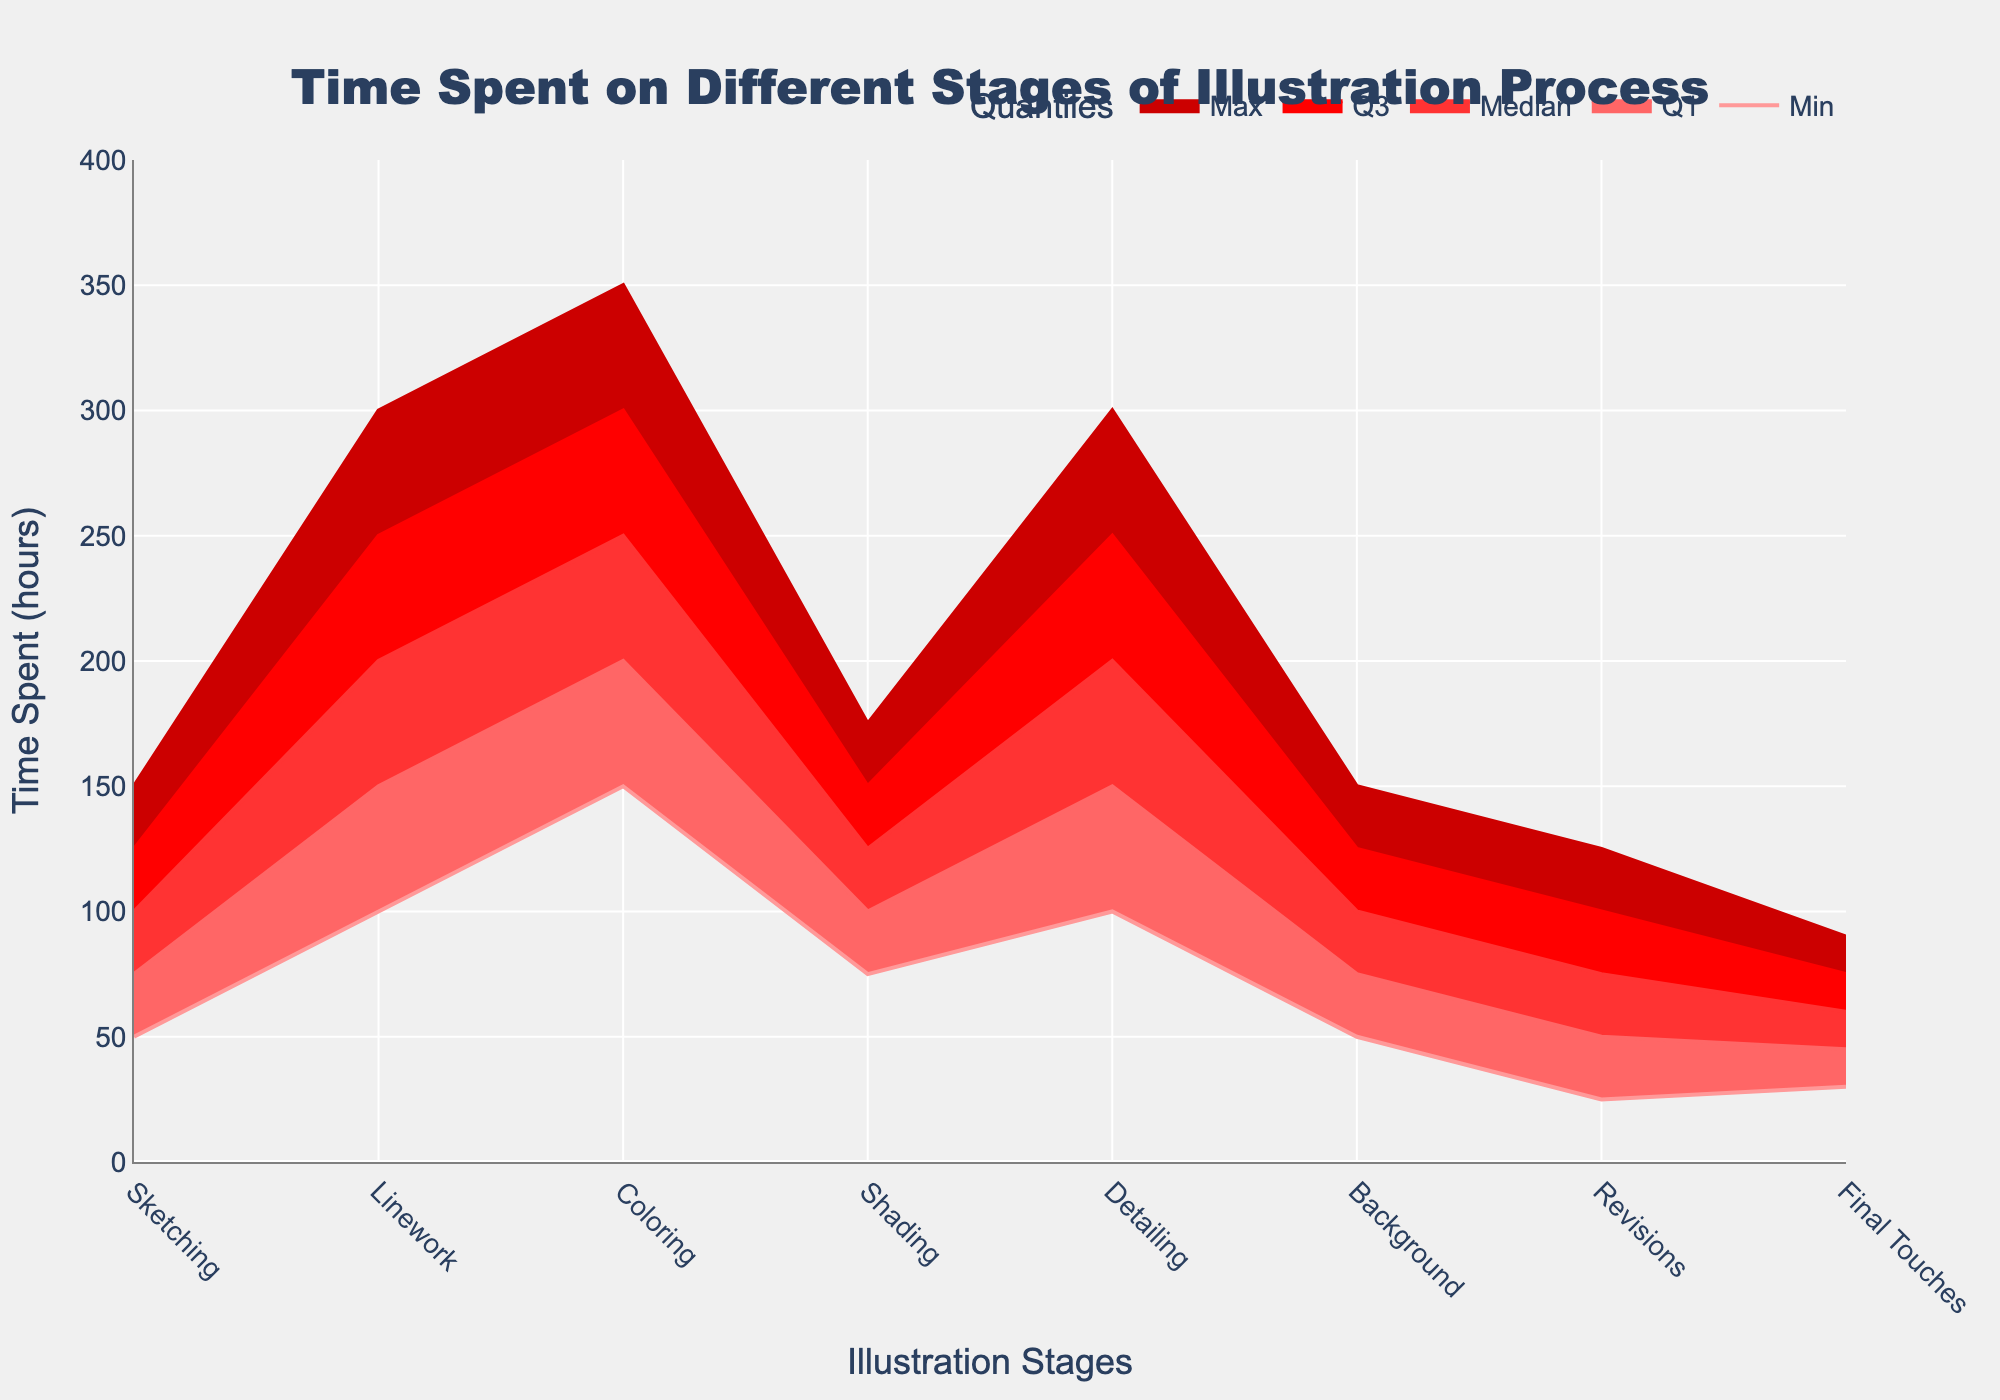How many stages are listed in the fan chart? To find the number of stages listed in the fan chart, count the unique stages labeled on the x-axis.
Answer: 8 What is the median time spent on the Coloring stage? Locate the stage "Coloring" on the x-axis, then identify the value corresponding to the "Median" line.
Answer: 250 hours Which stage has the highest maximum time spent? For each stage, note the value of the line representing the "Max" time. The stage with the highest value is the one with the maximum time spent.
Answer: Coloring What is the interquartile range (IQR) for the Shading stage? To calculate the IQR, subtract the Q1 value from the Q3 value for the Shading stage: Q3 - Q1.
Answer: 50 hours Compare the median times of Linework and Detailing stages. Which stage has a higher median time? Locate the values corresponding to the "Median" lines for both Linework and Detailing stages. Compare these values.
Answer: Linework What stage has the most consistency in time spent, based on the spread from Min to Max values? The stage with the smallest difference between its Min and Max values has the most consistent time spent. Calculate the difference for each stage and compare.
Answer: Final Touches What is the range of time spent on the Background stage? Subtract the Min value from the Max value for the Background stage to find the range (Max - Min).
Answer: 100 hours Which stages have a similar Q3 value for time spent? Identify the Q3 values for each stage and compare them to find stages with similar Q3 values.
Answer: Linework and Detailing What is the minimum time spent on Revisions? Locate the "Min" value for the Revisions stage on the chart.
Answer: 25 hours Compare the Q1 times of Sketching and Background stages. Which is lower? Identify the Q1 values for both Sketching and Background stages and compare them to find the lower value.
Answer: Background 